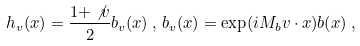Convert formula to latex. <formula><loc_0><loc_0><loc_500><loc_500>h _ { v } ( x ) = \frac { 1 + \not v } { 2 } b _ { v } ( x ) \, , \, b _ { v } ( x ) = \exp ( i M _ { b } v \cdot x ) b ( x ) \, ,</formula> 